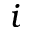Convert formula to latex. <formula><loc_0><loc_0><loc_500><loc_500>i</formula> 